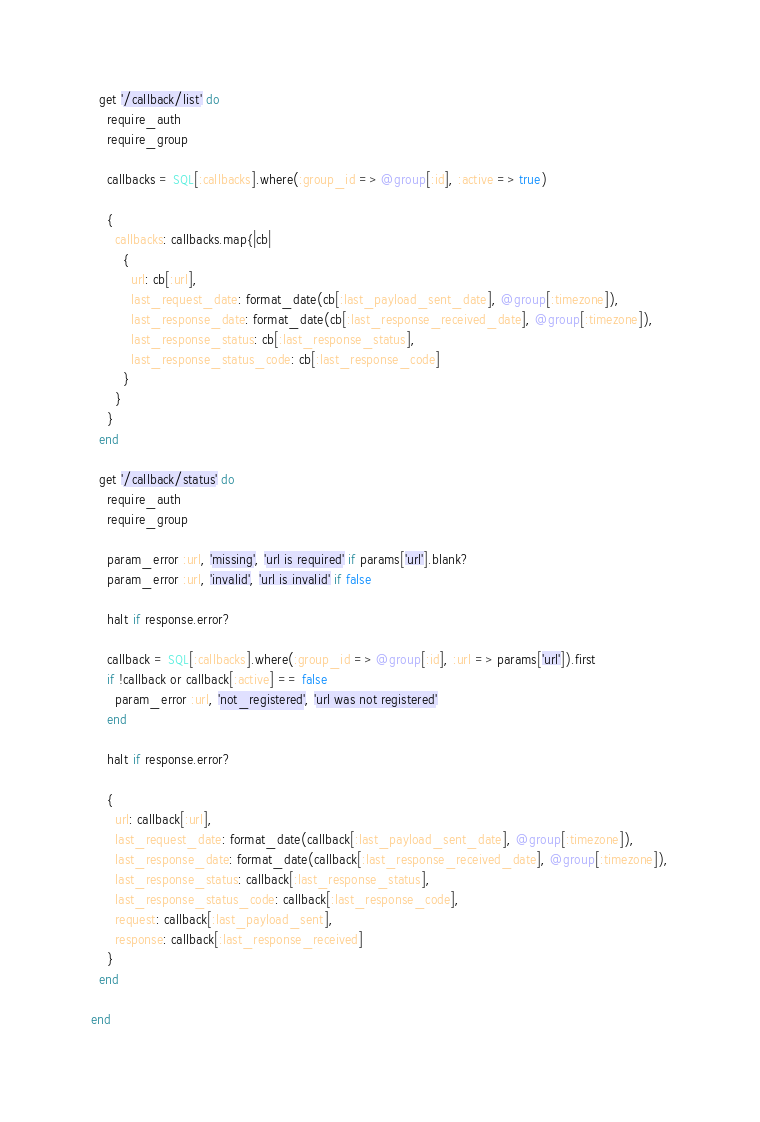Convert code to text. <code><loc_0><loc_0><loc_500><loc_500><_Ruby_>
  get '/callback/list' do
    require_auth
    require_group

    callbacks = SQL[:callbacks].where(:group_id => @group[:id], :active => true)

    {
      callbacks: callbacks.map{|cb|
        {
          url: cb[:url],
          last_request_date: format_date(cb[:last_payload_sent_date], @group[:timezone]),
          last_response_date: format_date(cb[:last_response_received_date], @group[:timezone]),
          last_response_status: cb[:last_response_status],
          last_response_status_code: cb[:last_response_code]
        }
      }
    }
  end

  get '/callback/status' do
    require_auth
    require_group

    param_error :url, 'missing', 'url is required' if params['url'].blank?
    param_error :url, 'invalid', 'url is invalid' if false

    halt if response.error?

    callback = SQL[:callbacks].where(:group_id => @group[:id], :url => params['url']).first
    if !callback or callback[:active] == false
      param_error :url, 'not_registered', 'url was not registered'
    end

    halt if response.error?

    {
      url: callback[:url],
      last_request_date: format_date(callback[:last_payload_sent_date], @group[:timezone]),
      last_response_date: format_date(callback[:last_response_received_date], @group[:timezone]),
      last_response_status: callback[:last_response_status],
      last_response_status_code: callback[:last_response_code],
      request: callback[:last_payload_sent],
      response: callback[:last_response_received]
    }
  end

end
</code> 